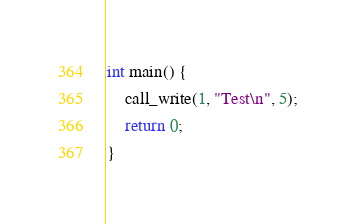<code> <loc_0><loc_0><loc_500><loc_500><_C_>

int main() {
    call_write(1, "Test\n", 5);
    return 0;
}
</code> 